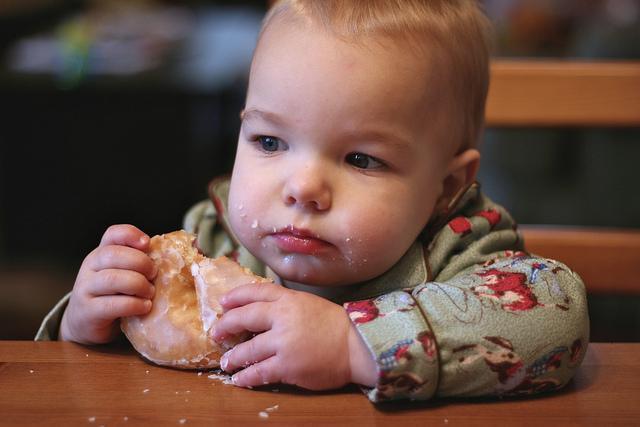How many cats are facing away?
Give a very brief answer. 0. 